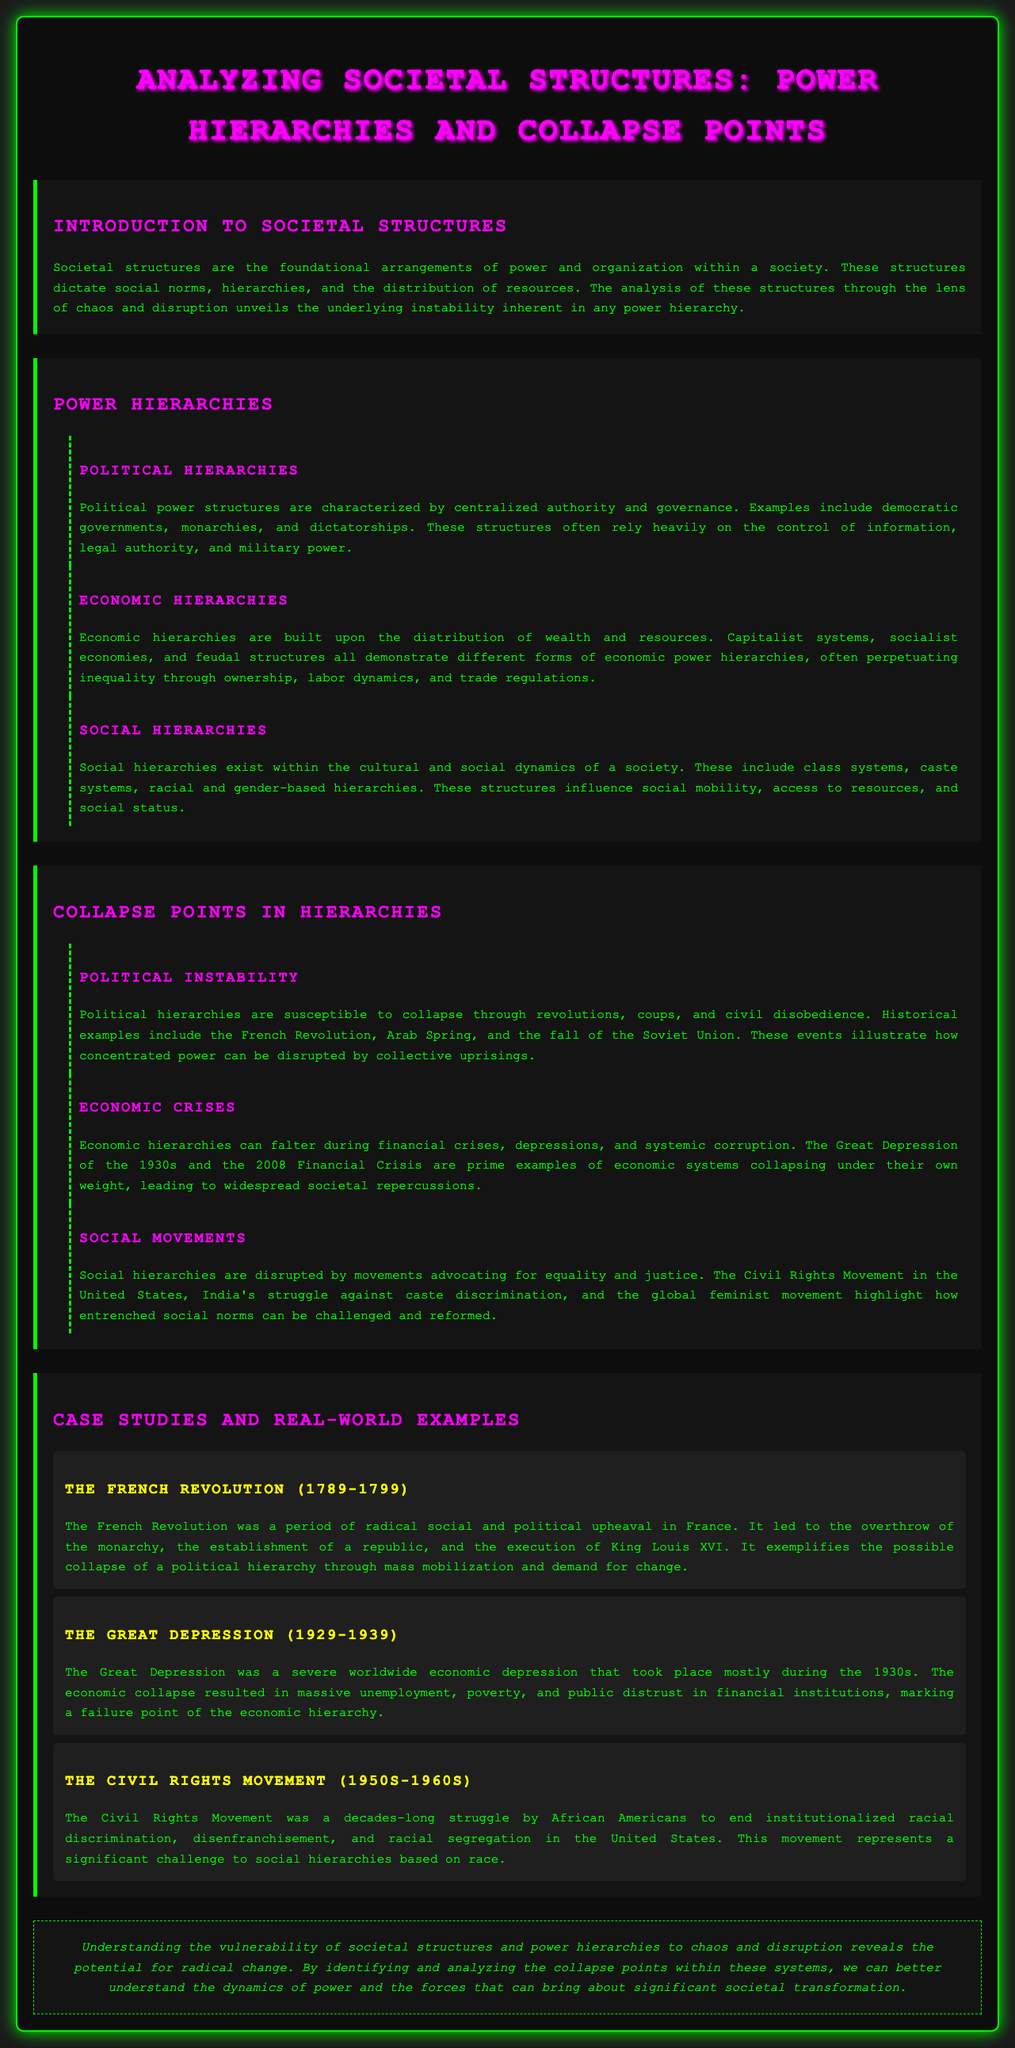What are the foundational arrangements of power and organization? The foundational arrangements of power and organization within a society are referred to as societal structures.
Answer: societal structures Which revolution is cited as an example of political instability? The document mentions the French Revolution as an example of political instability and collapse.
Answer: French Revolution What economic crisis is highlighted from the 1930s? The document discusses the Great Depression as a significant economic crisis from the 1930s.
Answer: Great Depression Which movement represents a challenge to social hierarchies based on race? The Civil Rights Movement is noted as a significant challenge to social hierarchies based on race.
Answer: Civil Rights Movement What is a common factor that leads to the collapse of political hierarchies? Collective uprisings are identified as a common factor leading to the collapse of political hierarchies.
Answer: collective uprisings What type of structure relies on the distribution of wealth and resources? Economic hierarchies rely on the distribution of wealth and resources.
Answer: Economic hierarchies Which case study exemplifies the collapse of political hierarchy? The French Revolution exemplifies the possible collapse of a political hierarchy.
Answer: French Revolution What is the overall theme of the document? The overall theme of the document revolves around the analysis of societal structures and power hierarchies.
Answer: analysis of societal structures and power hierarchies What do social movements aim to advocate for? Social movements aim to advocate for equality and justice.
Answer: equality and justice 